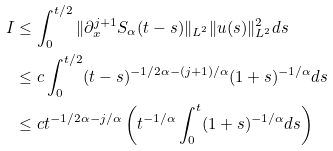<formula> <loc_0><loc_0><loc_500><loc_500>I & \leq \int _ { 0 } ^ { t / 2 } \| \partial _ { x } ^ { j + 1 } S _ { \alpha } ( t - s ) \| _ { L ^ { 2 } } \| u ( s ) \| _ { L ^ { 2 } } ^ { 2 } d s \\ & \leq c \int _ { 0 } ^ { t / 2 } ( t - s ) ^ { - 1 / 2 \alpha - ( j + 1 ) / \alpha } ( 1 + s ) ^ { - 1 / \alpha } d s \\ & \leq c t ^ { - 1 / 2 \alpha - j / \alpha } \left ( t ^ { - 1 / \alpha } \int _ { 0 } ^ { t } ( 1 + s ) ^ { - 1 / \alpha } d s \right )</formula> 